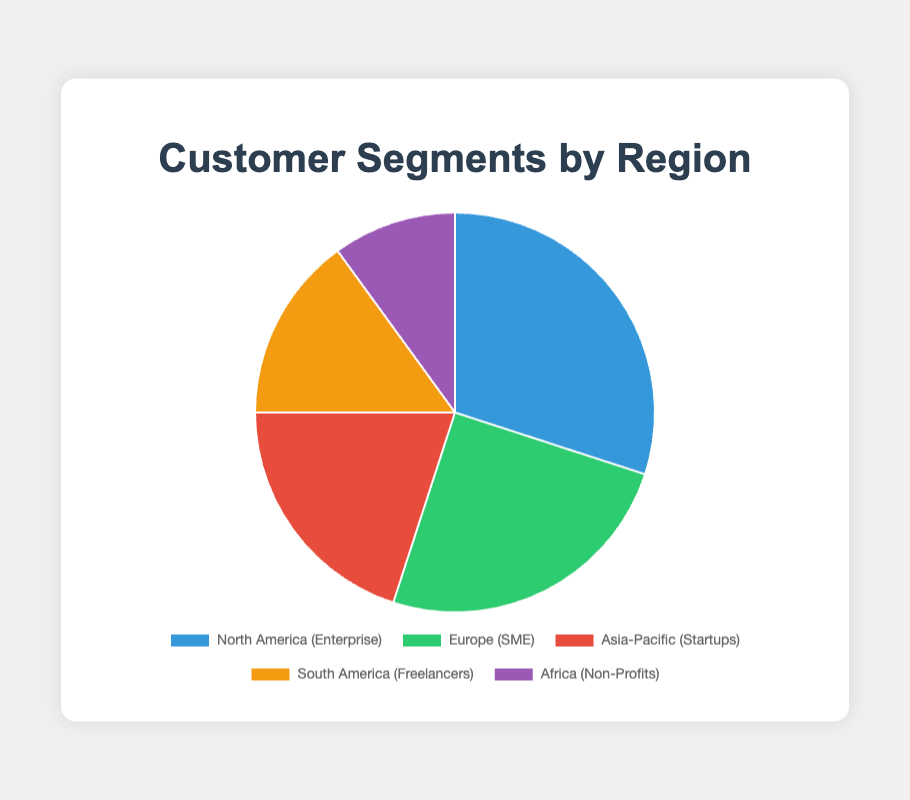Which customer segment has the highest percentage? By looking at the chart, the segment with the largest section will be the one with the highest percentage. North America (Enterprise) occupies the largest portion.
Answer: North America (Enterprise) Which region has the smallest customer segment? By observing the smallest slice of the pie chart, we see that Africa (Non-Profits) has the smallest section.
Answer: Africa (Non-Profits) What is the combined percentage of Europe (SME) and Asia-Pacific (Startups)? For the combined percentage, we add the percentages of Europe (SME) and Asia-Pacific (Startups). That's 25% + 20% = 45%.
Answer: 45% Which customer segment represents 15% of the distribution? By referring to the segment with a 15% slice in the chart, we find that South America (Freelancers) represents 15%.
Answer: South America (Freelancers) Is there any region where the customer segment percentage is less than 20%? We look for any segment with a slice representing less than 20%. South America (Freelancers) at 15% and Africa (Non-Profits) at 10% fit this criterion.
Answer: Yes, South America and Africa Which segments collectively make up more than half of the chart? To determine this, sum the largest segments until they exceed 50%. North America (Enterprise) is 30%, and Europe (SME) is 25%. Together they make up 55%.
Answer: North America (Enterprise) and Europe (SME) Compare the percentage of Asia-Pacific (Startups) to South America (Freelancers). Which is greater? To compare, look at their percentages: Asia-Pacific (Startups) is 20% while South America (Freelancers) is 15%. Asia-Pacific (Startups) is greater.
Answer: Asia-Pacific (Startups) What is the average percentage of all five customer segments? To find the average, sum all percentages and divide by the number of segments: (30 + 25 + 20 + 15 + 10) / 5 = 20%.
Answer: 20% Which customer segment is represented by the green section of the pie chart? By identifying the section colored green, it corresponds to Europe (SME).
Answer: Europe (SME) How much more percentage does North America (Enterprise) have compared to Africa (Non-Profits)? Subtract Africa’s percentage from North America's: 30% - 10% = 20%.
Answer: 20% 